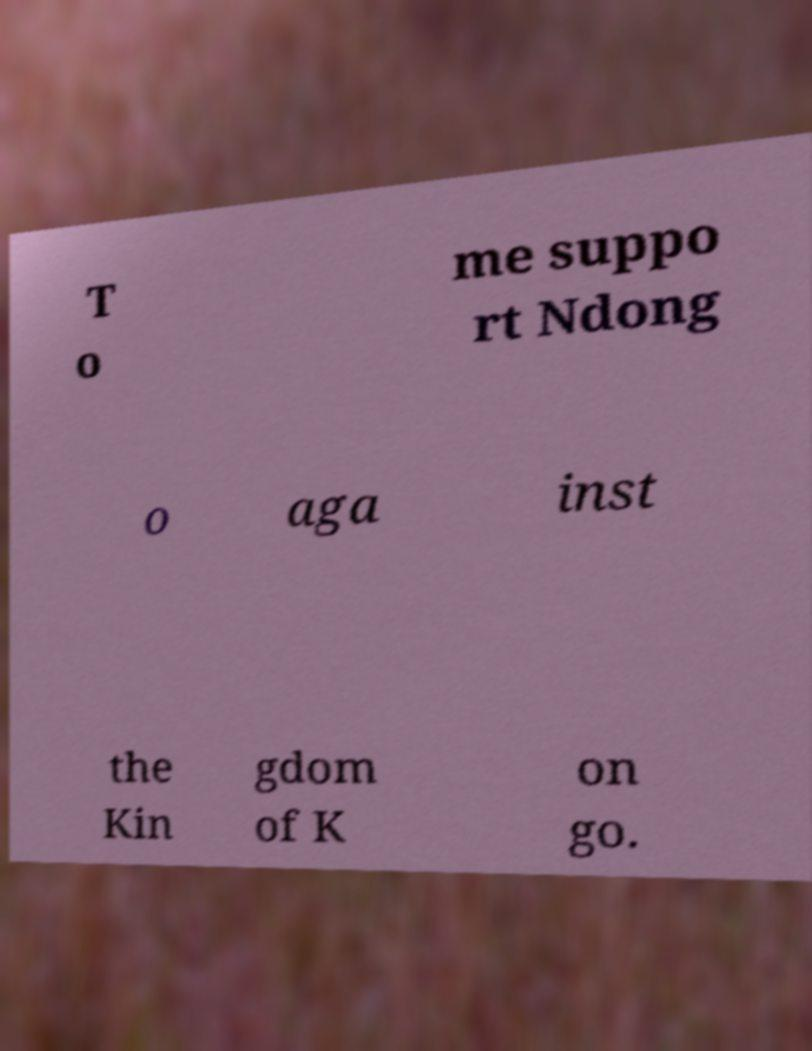Could you extract and type out the text from this image? T o me suppo rt Ndong o aga inst the Kin gdom of K on go. 